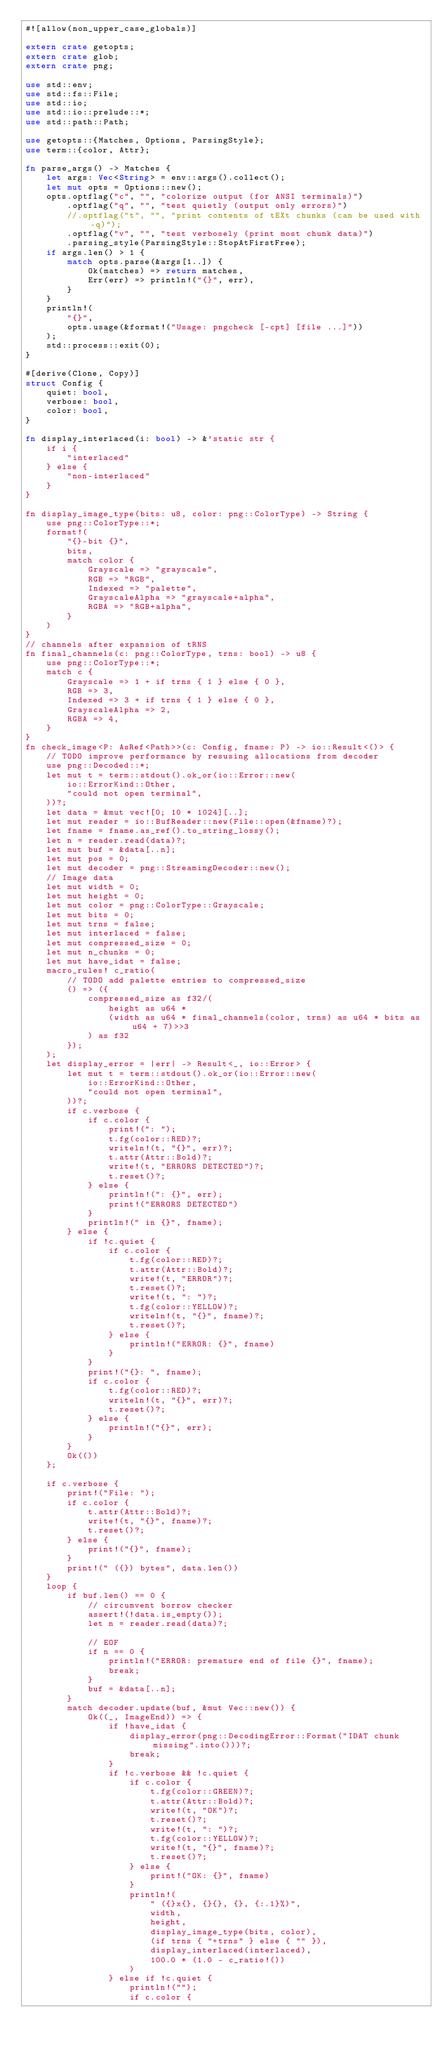<code> <loc_0><loc_0><loc_500><loc_500><_Rust_>#![allow(non_upper_case_globals)]

extern crate getopts;
extern crate glob;
extern crate png;

use std::env;
use std::fs::File;
use std::io;
use std::io::prelude::*;
use std::path::Path;

use getopts::{Matches, Options, ParsingStyle};
use term::{color, Attr};

fn parse_args() -> Matches {
    let args: Vec<String> = env::args().collect();
    let mut opts = Options::new();
    opts.optflag("c", "", "colorize output (for ANSI terminals)")
        .optflag("q", "", "test quietly (output only errors)")
        //.optflag("t", "", "print contents of tEXt chunks (can be used with -q)");
        .optflag("v", "", "test verbosely (print most chunk data)")
        .parsing_style(ParsingStyle::StopAtFirstFree);
    if args.len() > 1 {
        match opts.parse(&args[1..]) {
            Ok(matches) => return matches,
            Err(err) => println!("{}", err),
        }
    }
    println!(
        "{}",
        opts.usage(&format!("Usage: pngcheck [-cpt] [file ...]"))
    );
    std::process::exit(0);
}

#[derive(Clone, Copy)]
struct Config {
    quiet: bool,
    verbose: bool,
    color: bool,
}

fn display_interlaced(i: bool) -> &'static str {
    if i {
        "interlaced"
    } else {
        "non-interlaced"
    }
}

fn display_image_type(bits: u8, color: png::ColorType) -> String {
    use png::ColorType::*;
    format!(
        "{}-bit {}",
        bits,
        match color {
            Grayscale => "grayscale",
            RGB => "RGB",
            Indexed => "palette",
            GrayscaleAlpha => "grayscale+alpha",
            RGBA => "RGB+alpha",
        }
    )
}
// channels after expansion of tRNS
fn final_channels(c: png::ColorType, trns: bool) -> u8 {
    use png::ColorType::*;
    match c {
        Grayscale => 1 + if trns { 1 } else { 0 },
        RGB => 3,
        Indexed => 3 + if trns { 1 } else { 0 },
        GrayscaleAlpha => 2,
        RGBA => 4,
    }
}
fn check_image<P: AsRef<Path>>(c: Config, fname: P) -> io::Result<()> {
    // TODO improve performance by resusing allocations from decoder
    use png::Decoded::*;
    let mut t = term::stdout().ok_or(io::Error::new(
        io::ErrorKind::Other,
        "could not open terminal",
    ))?;
    let data = &mut vec![0; 10 * 1024][..];
    let mut reader = io::BufReader::new(File::open(&fname)?);
    let fname = fname.as_ref().to_string_lossy();
    let n = reader.read(data)?;
    let mut buf = &data[..n];
    let mut pos = 0;
    let mut decoder = png::StreamingDecoder::new();
    // Image data
    let mut width = 0;
    let mut height = 0;
    let mut color = png::ColorType::Grayscale;
    let mut bits = 0;
    let mut trns = false;
    let mut interlaced = false;
    let mut compressed_size = 0;
    let mut n_chunks = 0;
    let mut have_idat = false;
    macro_rules! c_ratio(
        // TODO add palette entries to compressed_size
        () => ({
            compressed_size as f32/(
                height as u64 *
                (width as u64 * final_channels(color, trns) as u64 * bits as u64 + 7)>>3
            ) as f32
        });
    );
    let display_error = |err| -> Result<_, io::Error> {
        let mut t = term::stdout().ok_or(io::Error::new(
            io::ErrorKind::Other,
            "could not open terminal",
        ))?;
        if c.verbose {
            if c.color {
                print!(": ");
                t.fg(color::RED)?;
                writeln!(t, "{}", err)?;
                t.attr(Attr::Bold)?;
                write!(t, "ERRORS DETECTED")?;
                t.reset()?;
            } else {
                println!(": {}", err);
                print!("ERRORS DETECTED")
            }
            println!(" in {}", fname);
        } else {
            if !c.quiet {
                if c.color {
                    t.fg(color::RED)?;
                    t.attr(Attr::Bold)?;
                    write!(t, "ERROR")?;
                    t.reset()?;
                    write!(t, ": ")?;
                    t.fg(color::YELLOW)?;
                    writeln!(t, "{}", fname)?;
                    t.reset()?;
                } else {
                    println!("ERROR: {}", fname)
                }
            }
            print!("{}: ", fname);
            if c.color {
                t.fg(color::RED)?;
                writeln!(t, "{}", err)?;
                t.reset()?;
            } else {
                println!("{}", err);
            }
        }
        Ok(())
    };

    if c.verbose {
        print!("File: ");
        if c.color {
            t.attr(Attr::Bold)?;
            write!(t, "{}", fname)?;
            t.reset()?;
        } else {
            print!("{}", fname);
        }
        print!(" ({}) bytes", data.len())
    }
    loop {
        if buf.len() == 0 {
            // circumvent borrow checker
            assert!(!data.is_empty());
            let n = reader.read(data)?;

            // EOF
            if n == 0 {
                println!("ERROR: premature end of file {}", fname);
                break;
            }
            buf = &data[..n];
        }
        match decoder.update(buf, &mut Vec::new()) {
            Ok((_, ImageEnd)) => {
                if !have_idat {
                    display_error(png::DecodingError::Format("IDAT chunk missing".into()))?;
                    break;
                }
                if !c.verbose && !c.quiet {
                    if c.color {
                        t.fg(color::GREEN)?;
                        t.attr(Attr::Bold)?;
                        write!(t, "OK")?;
                        t.reset()?;
                        write!(t, ": ")?;
                        t.fg(color::YELLOW)?;
                        write!(t, "{}", fname)?;
                        t.reset()?;
                    } else {
                        print!("OK: {}", fname)
                    }
                    println!(
                        " ({}x{}, {}{}, {}, {:.1}%)",
                        width,
                        height,
                        display_image_type(bits, color),
                        (if trns { "+trns" } else { "" }),
                        display_interlaced(interlaced),
                        100.0 * (1.0 - c_ratio!())
                    )
                } else if !c.quiet {
                    println!("");
                    if c.color {</code> 